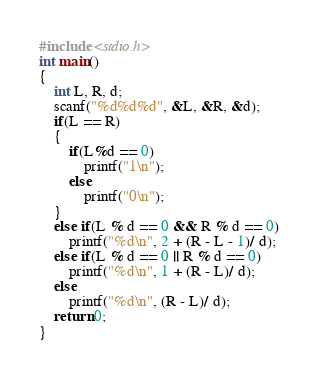Convert code to text. <code><loc_0><loc_0><loc_500><loc_500><_C_>#include <stdio.h>
int main()
{
    int L, R, d;
	scanf("%d%d%d", &L, &R, &d);
	if(L == R)
	{
	    if(L%d == 0)
	        printf("1\n");
	    else
	        printf("0\n");
	}
	else if(L % d == 0 && R % d == 0)
		printf("%d\n", 2 + (R - L - 1)/ d);
	else if(L % d == 0 || R % d == 0)
	    printf("%d\n", 1 + (R - L)/ d);
	else
	    printf("%d\n", (R - L)/ d);
	return 0;
}</code> 